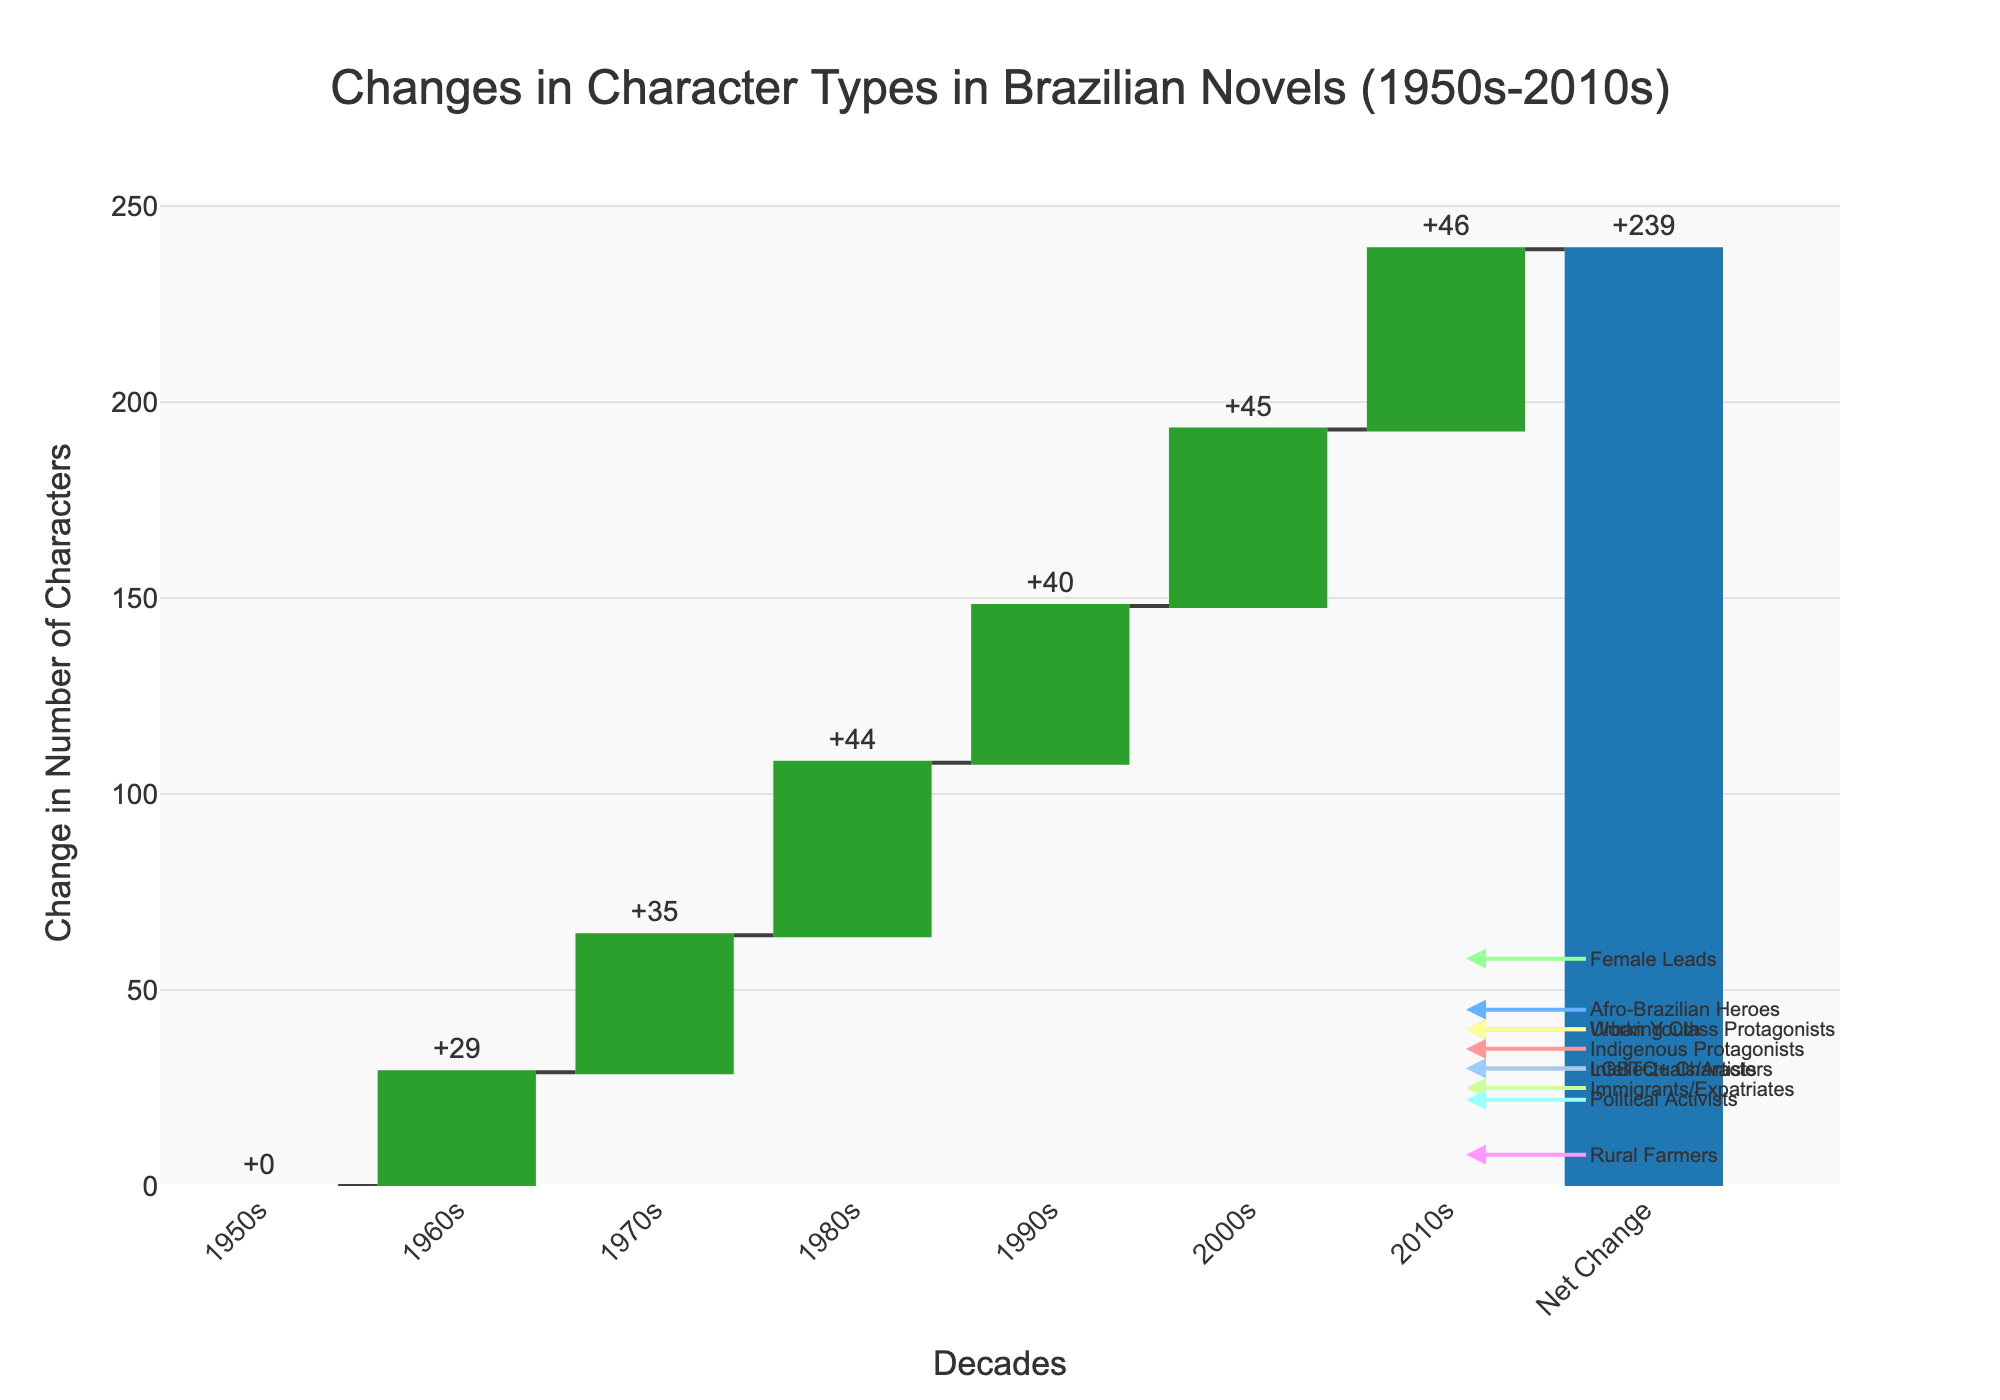What is the title of the figure? The title is usually located at the top of the chart and gives an overview of the data being presented.
Answer: Changes in Character Types in Brazilian Novels (1950s-2010s) What is the total change displayed in the last bar of the chart? The total change is shown in the final bar, labeled "Net Change." It represents the cumulative change across all decades.
Answer: +357 Which character type showed the highest increase from the 1950s to the 2010s? To determine this, look at the changes from the first decade (1950s) to the last (2010s) for each character type.
Answer: Female Leads By how much did Indigenous Protagonists increase from the 1950s to the 2010s? Subtract the value in the 1950s from the value in the 2010s for Indigenous Protagonists (35 - 5).
Answer: 30 Which two character types had the smallest increase? To find this, compare the changes in values for each character type from the 1950s to the 2010s and identify the two smallest increments.
Answer: Rural Farmers and Intellectuals/Artists What is the net change for the character type "Afro-Brazilian Heroes"? Identify the change for "Afro-Brazilian Heroes" from different decades and verify if the net change sum follows the displayed figure. (45 - 3).
Answer: 42 How many decades are shown on the x-axis? Count the number of distinct decades starting from the 1950s to 2010s plus one representing total.
Answer: 8 Which character type had a decreasing trend? Observe which character type saw declines when moving from the 1950s to the 2010s.
Answer: Rural Farmers How many character types had their last value in the 2010s annotated with arrows? Look at the figure to count how many character types have their respective arrows pointing to their positions in the 2010s.
Answer: 10 